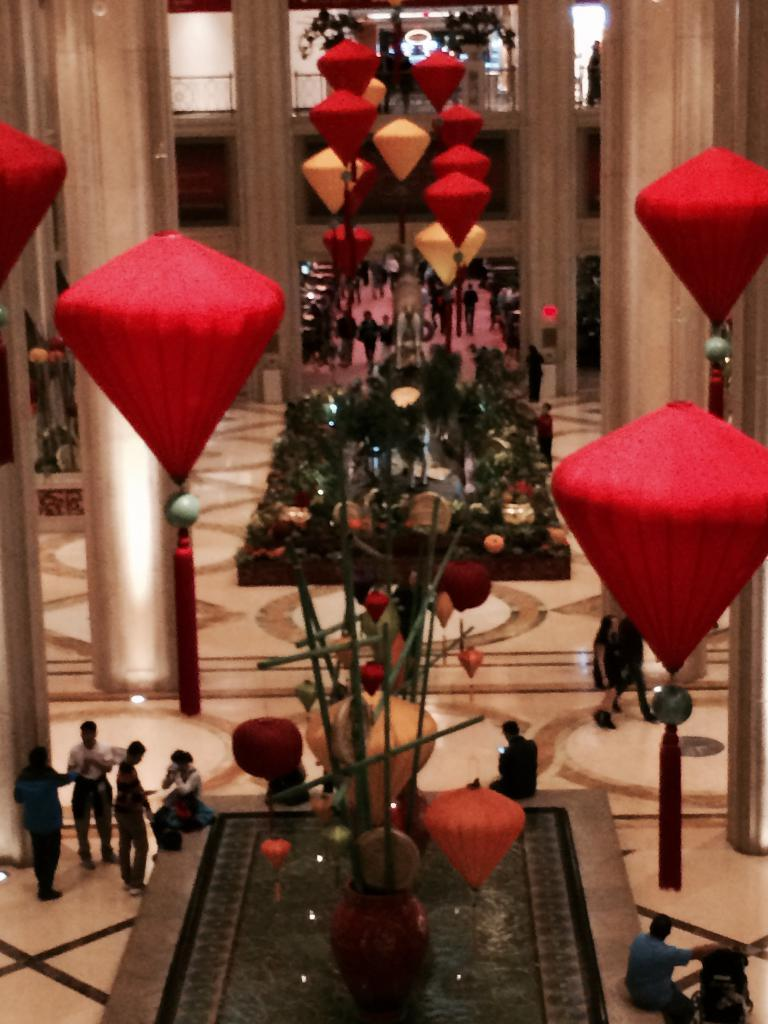What type of space is depicted in the image? There is a huge hall in the picture. What architectural features can be seen in the hall? There are pillars in the hall. Are there any people present in the image? Yes, there are people around the pillars. What can be seen hanging from the roof in the hall? There are decorations hanging from the roof. Can you see any clouds inside the hall in the image? No, there are no clouds visible inside the hall in the image. Are there any matches being used by the people in the image? There is no indication of matches or any similar objects being used by the people in the image. 